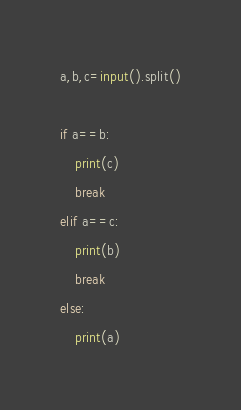Convert code to text. <code><loc_0><loc_0><loc_500><loc_500><_Python_>a,b,c=input().split()

if a==b:
    print(c)
    break
elif a==c:
    print(b)
    break
else:
    print(a)</code> 